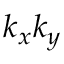<formula> <loc_0><loc_0><loc_500><loc_500>k _ { x } k _ { y }</formula> 